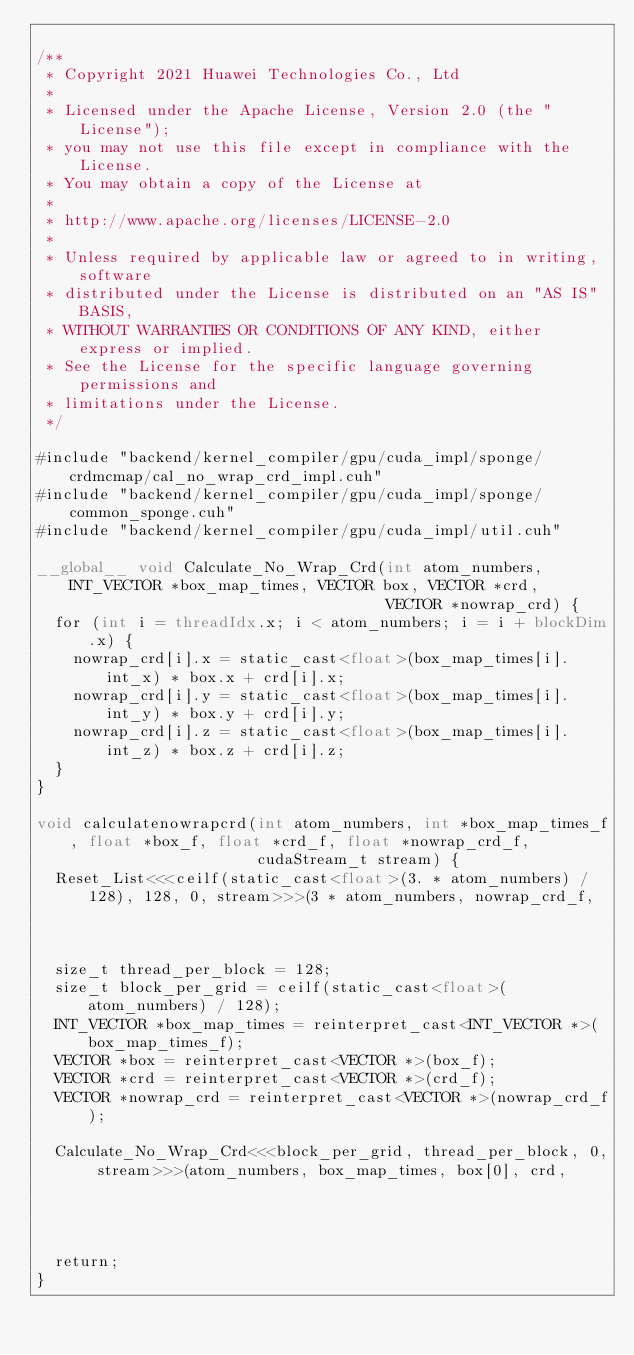Convert code to text. <code><loc_0><loc_0><loc_500><loc_500><_Cuda_>
/**
 * Copyright 2021 Huawei Technologies Co., Ltd
 *
 * Licensed under the Apache License, Version 2.0 (the "License");
 * you may not use this file except in compliance with the License.
 * You may obtain a copy of the License at
 *
 * http://www.apache.org/licenses/LICENSE-2.0
 *
 * Unless required by applicable law or agreed to in writing, software
 * distributed under the License is distributed on an "AS IS" BASIS,
 * WITHOUT WARRANTIES OR CONDITIONS OF ANY KIND, either express or implied.
 * See the License for the specific language governing permissions and
 * limitations under the License.
 */

#include "backend/kernel_compiler/gpu/cuda_impl/sponge/crdmcmap/cal_no_wrap_crd_impl.cuh"
#include "backend/kernel_compiler/gpu/cuda_impl/sponge/common_sponge.cuh"
#include "backend/kernel_compiler/gpu/cuda_impl/util.cuh"

__global__ void Calculate_No_Wrap_Crd(int atom_numbers, INT_VECTOR *box_map_times, VECTOR box, VECTOR *crd,
                                      VECTOR *nowrap_crd) {
  for (int i = threadIdx.x; i < atom_numbers; i = i + blockDim.x) {
    nowrap_crd[i].x = static_cast<float>(box_map_times[i].int_x) * box.x + crd[i].x;
    nowrap_crd[i].y = static_cast<float>(box_map_times[i].int_y) * box.y + crd[i].y;
    nowrap_crd[i].z = static_cast<float>(box_map_times[i].int_z) * box.z + crd[i].z;
  }
}

void calculatenowrapcrd(int atom_numbers, int *box_map_times_f, float *box_f, float *crd_f, float *nowrap_crd_f,
                        cudaStream_t stream) {
  Reset_List<<<ceilf(static_cast<float>(3. * atom_numbers) / 128), 128, 0, stream>>>(3 * atom_numbers, nowrap_crd_f,
                                                                                     0.);
  size_t thread_per_block = 128;
  size_t block_per_grid = ceilf(static_cast<float>(atom_numbers) / 128);
  INT_VECTOR *box_map_times = reinterpret_cast<INT_VECTOR *>(box_map_times_f);
  VECTOR *box = reinterpret_cast<VECTOR *>(box_f);
  VECTOR *crd = reinterpret_cast<VECTOR *>(crd_f);
  VECTOR *nowrap_crd = reinterpret_cast<VECTOR *>(nowrap_crd_f);

  Calculate_No_Wrap_Crd<<<block_per_grid, thread_per_block, 0, stream>>>(atom_numbers, box_map_times, box[0], crd,
                                                                         nowrap_crd);
  return;
}
</code> 